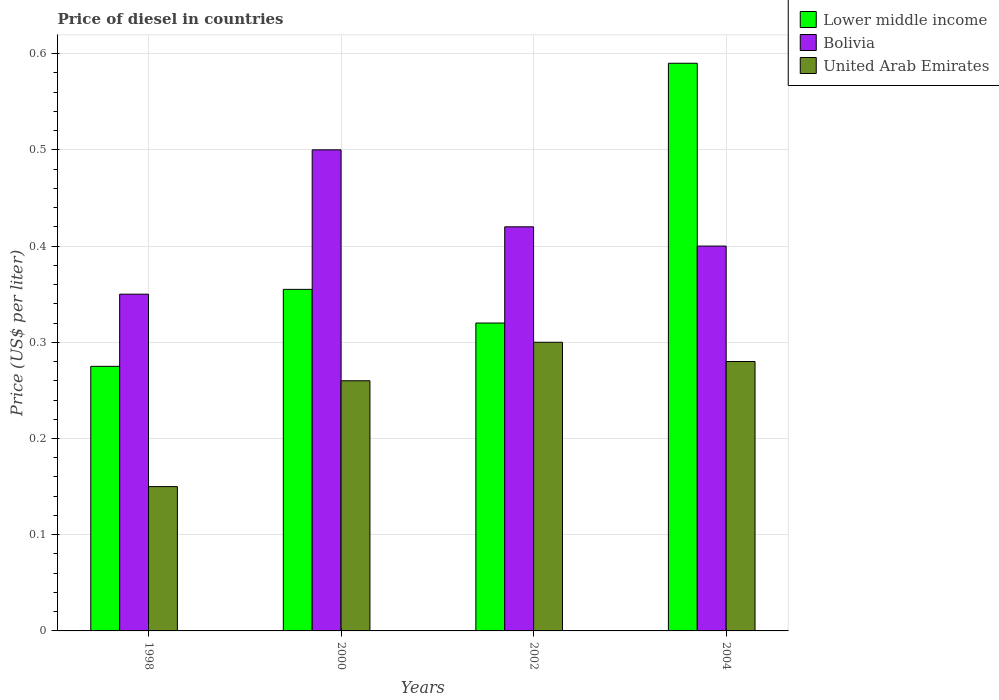Are the number of bars per tick equal to the number of legend labels?
Keep it short and to the point. Yes. What is the label of the 3rd group of bars from the left?
Offer a very short reply. 2002. In how many cases, is the number of bars for a given year not equal to the number of legend labels?
Your answer should be very brief. 0. What is the price of diesel in Lower middle income in 2002?
Provide a succinct answer. 0.32. Across all years, what is the maximum price of diesel in Bolivia?
Your answer should be compact. 0.5. Across all years, what is the minimum price of diesel in Lower middle income?
Your response must be concise. 0.28. In which year was the price of diesel in Bolivia maximum?
Offer a terse response. 2000. In which year was the price of diesel in Lower middle income minimum?
Offer a terse response. 1998. What is the difference between the price of diesel in United Arab Emirates in 2000 and that in 2004?
Offer a very short reply. -0.02. What is the difference between the price of diesel in Bolivia in 2002 and the price of diesel in United Arab Emirates in 2004?
Your answer should be very brief. 0.14. What is the average price of diesel in United Arab Emirates per year?
Keep it short and to the point. 0.25. In the year 2002, what is the difference between the price of diesel in United Arab Emirates and price of diesel in Bolivia?
Offer a very short reply. -0.12. What is the ratio of the price of diesel in United Arab Emirates in 1998 to that in 2000?
Provide a short and direct response. 0.58. What is the difference between the highest and the second highest price of diesel in Bolivia?
Provide a succinct answer. 0.08. What is the difference between the highest and the lowest price of diesel in Bolivia?
Offer a terse response. 0.15. In how many years, is the price of diesel in Bolivia greater than the average price of diesel in Bolivia taken over all years?
Ensure brevity in your answer.  2. Is the sum of the price of diesel in Bolivia in 2002 and 2004 greater than the maximum price of diesel in United Arab Emirates across all years?
Your answer should be very brief. Yes. What does the 3rd bar from the left in 2000 represents?
Ensure brevity in your answer.  United Arab Emirates. What does the 1st bar from the right in 2004 represents?
Give a very brief answer. United Arab Emirates. How many years are there in the graph?
Provide a short and direct response. 4. What is the difference between two consecutive major ticks on the Y-axis?
Keep it short and to the point. 0.1. Are the values on the major ticks of Y-axis written in scientific E-notation?
Keep it short and to the point. No. How many legend labels are there?
Give a very brief answer. 3. How are the legend labels stacked?
Offer a very short reply. Vertical. What is the title of the graph?
Offer a very short reply. Price of diesel in countries. What is the label or title of the Y-axis?
Your response must be concise. Price (US$ per liter). What is the Price (US$ per liter) of Lower middle income in 1998?
Ensure brevity in your answer.  0.28. What is the Price (US$ per liter) of Bolivia in 1998?
Provide a short and direct response. 0.35. What is the Price (US$ per liter) of Lower middle income in 2000?
Offer a very short reply. 0.35. What is the Price (US$ per liter) of Bolivia in 2000?
Offer a very short reply. 0.5. What is the Price (US$ per liter) of United Arab Emirates in 2000?
Your response must be concise. 0.26. What is the Price (US$ per liter) in Lower middle income in 2002?
Provide a short and direct response. 0.32. What is the Price (US$ per liter) in Bolivia in 2002?
Your answer should be compact. 0.42. What is the Price (US$ per liter) in Lower middle income in 2004?
Your answer should be very brief. 0.59. What is the Price (US$ per liter) of United Arab Emirates in 2004?
Make the answer very short. 0.28. Across all years, what is the maximum Price (US$ per liter) in Lower middle income?
Offer a terse response. 0.59. Across all years, what is the minimum Price (US$ per liter) of Lower middle income?
Ensure brevity in your answer.  0.28. Across all years, what is the minimum Price (US$ per liter) of Bolivia?
Provide a succinct answer. 0.35. What is the total Price (US$ per liter) in Lower middle income in the graph?
Keep it short and to the point. 1.54. What is the total Price (US$ per liter) of Bolivia in the graph?
Offer a very short reply. 1.67. What is the difference between the Price (US$ per liter) in Lower middle income in 1998 and that in 2000?
Provide a short and direct response. -0.08. What is the difference between the Price (US$ per liter) of Bolivia in 1998 and that in 2000?
Provide a short and direct response. -0.15. What is the difference between the Price (US$ per liter) in United Arab Emirates in 1998 and that in 2000?
Ensure brevity in your answer.  -0.11. What is the difference between the Price (US$ per liter) of Lower middle income in 1998 and that in 2002?
Provide a short and direct response. -0.04. What is the difference between the Price (US$ per liter) of Bolivia in 1998 and that in 2002?
Ensure brevity in your answer.  -0.07. What is the difference between the Price (US$ per liter) in United Arab Emirates in 1998 and that in 2002?
Make the answer very short. -0.15. What is the difference between the Price (US$ per liter) in Lower middle income in 1998 and that in 2004?
Your response must be concise. -0.32. What is the difference between the Price (US$ per liter) of United Arab Emirates in 1998 and that in 2004?
Provide a short and direct response. -0.13. What is the difference between the Price (US$ per liter) of Lower middle income in 2000 and that in 2002?
Your response must be concise. 0.04. What is the difference between the Price (US$ per liter) of United Arab Emirates in 2000 and that in 2002?
Offer a terse response. -0.04. What is the difference between the Price (US$ per liter) in Lower middle income in 2000 and that in 2004?
Your answer should be compact. -0.23. What is the difference between the Price (US$ per liter) in Bolivia in 2000 and that in 2004?
Give a very brief answer. 0.1. What is the difference between the Price (US$ per liter) of United Arab Emirates in 2000 and that in 2004?
Your response must be concise. -0.02. What is the difference between the Price (US$ per liter) in Lower middle income in 2002 and that in 2004?
Provide a succinct answer. -0.27. What is the difference between the Price (US$ per liter) of Bolivia in 2002 and that in 2004?
Offer a very short reply. 0.02. What is the difference between the Price (US$ per liter) of Lower middle income in 1998 and the Price (US$ per liter) of Bolivia in 2000?
Ensure brevity in your answer.  -0.23. What is the difference between the Price (US$ per liter) in Lower middle income in 1998 and the Price (US$ per liter) in United Arab Emirates in 2000?
Your response must be concise. 0.01. What is the difference between the Price (US$ per liter) in Bolivia in 1998 and the Price (US$ per liter) in United Arab Emirates in 2000?
Your answer should be compact. 0.09. What is the difference between the Price (US$ per liter) of Lower middle income in 1998 and the Price (US$ per liter) of Bolivia in 2002?
Keep it short and to the point. -0.14. What is the difference between the Price (US$ per liter) of Lower middle income in 1998 and the Price (US$ per liter) of United Arab Emirates in 2002?
Provide a succinct answer. -0.03. What is the difference between the Price (US$ per liter) in Lower middle income in 1998 and the Price (US$ per liter) in Bolivia in 2004?
Your answer should be compact. -0.12. What is the difference between the Price (US$ per liter) in Lower middle income in 1998 and the Price (US$ per liter) in United Arab Emirates in 2004?
Ensure brevity in your answer.  -0.01. What is the difference between the Price (US$ per liter) of Bolivia in 1998 and the Price (US$ per liter) of United Arab Emirates in 2004?
Provide a succinct answer. 0.07. What is the difference between the Price (US$ per liter) of Lower middle income in 2000 and the Price (US$ per liter) of Bolivia in 2002?
Provide a short and direct response. -0.07. What is the difference between the Price (US$ per liter) of Lower middle income in 2000 and the Price (US$ per liter) of United Arab Emirates in 2002?
Your answer should be very brief. 0.06. What is the difference between the Price (US$ per liter) in Bolivia in 2000 and the Price (US$ per liter) in United Arab Emirates in 2002?
Offer a terse response. 0.2. What is the difference between the Price (US$ per liter) in Lower middle income in 2000 and the Price (US$ per liter) in Bolivia in 2004?
Make the answer very short. -0.04. What is the difference between the Price (US$ per liter) of Lower middle income in 2000 and the Price (US$ per liter) of United Arab Emirates in 2004?
Keep it short and to the point. 0.07. What is the difference between the Price (US$ per liter) of Bolivia in 2000 and the Price (US$ per liter) of United Arab Emirates in 2004?
Make the answer very short. 0.22. What is the difference between the Price (US$ per liter) in Lower middle income in 2002 and the Price (US$ per liter) in Bolivia in 2004?
Offer a terse response. -0.08. What is the difference between the Price (US$ per liter) of Bolivia in 2002 and the Price (US$ per liter) of United Arab Emirates in 2004?
Provide a short and direct response. 0.14. What is the average Price (US$ per liter) in Lower middle income per year?
Your answer should be compact. 0.39. What is the average Price (US$ per liter) of Bolivia per year?
Your response must be concise. 0.42. What is the average Price (US$ per liter) in United Arab Emirates per year?
Offer a terse response. 0.25. In the year 1998, what is the difference between the Price (US$ per liter) of Lower middle income and Price (US$ per liter) of Bolivia?
Your answer should be very brief. -0.07. In the year 1998, what is the difference between the Price (US$ per liter) of Lower middle income and Price (US$ per liter) of United Arab Emirates?
Your response must be concise. 0.12. In the year 2000, what is the difference between the Price (US$ per liter) in Lower middle income and Price (US$ per liter) in Bolivia?
Ensure brevity in your answer.  -0.14. In the year 2000, what is the difference between the Price (US$ per liter) of Lower middle income and Price (US$ per liter) of United Arab Emirates?
Offer a very short reply. 0.1. In the year 2000, what is the difference between the Price (US$ per liter) in Bolivia and Price (US$ per liter) in United Arab Emirates?
Offer a terse response. 0.24. In the year 2002, what is the difference between the Price (US$ per liter) of Lower middle income and Price (US$ per liter) of United Arab Emirates?
Provide a short and direct response. 0.02. In the year 2002, what is the difference between the Price (US$ per liter) of Bolivia and Price (US$ per liter) of United Arab Emirates?
Offer a very short reply. 0.12. In the year 2004, what is the difference between the Price (US$ per liter) of Lower middle income and Price (US$ per liter) of Bolivia?
Your answer should be very brief. 0.19. In the year 2004, what is the difference between the Price (US$ per liter) of Lower middle income and Price (US$ per liter) of United Arab Emirates?
Ensure brevity in your answer.  0.31. In the year 2004, what is the difference between the Price (US$ per liter) in Bolivia and Price (US$ per liter) in United Arab Emirates?
Your answer should be very brief. 0.12. What is the ratio of the Price (US$ per liter) in Lower middle income in 1998 to that in 2000?
Provide a succinct answer. 0.77. What is the ratio of the Price (US$ per liter) of United Arab Emirates in 1998 to that in 2000?
Your response must be concise. 0.58. What is the ratio of the Price (US$ per liter) of Lower middle income in 1998 to that in 2002?
Your answer should be compact. 0.86. What is the ratio of the Price (US$ per liter) of United Arab Emirates in 1998 to that in 2002?
Offer a terse response. 0.5. What is the ratio of the Price (US$ per liter) in Lower middle income in 1998 to that in 2004?
Make the answer very short. 0.47. What is the ratio of the Price (US$ per liter) in United Arab Emirates in 1998 to that in 2004?
Ensure brevity in your answer.  0.54. What is the ratio of the Price (US$ per liter) of Lower middle income in 2000 to that in 2002?
Make the answer very short. 1.11. What is the ratio of the Price (US$ per liter) in Bolivia in 2000 to that in 2002?
Your response must be concise. 1.19. What is the ratio of the Price (US$ per liter) in United Arab Emirates in 2000 to that in 2002?
Provide a succinct answer. 0.87. What is the ratio of the Price (US$ per liter) in Lower middle income in 2000 to that in 2004?
Keep it short and to the point. 0.6. What is the ratio of the Price (US$ per liter) of United Arab Emirates in 2000 to that in 2004?
Provide a succinct answer. 0.93. What is the ratio of the Price (US$ per liter) in Lower middle income in 2002 to that in 2004?
Ensure brevity in your answer.  0.54. What is the ratio of the Price (US$ per liter) in Bolivia in 2002 to that in 2004?
Ensure brevity in your answer.  1.05. What is the ratio of the Price (US$ per liter) of United Arab Emirates in 2002 to that in 2004?
Give a very brief answer. 1.07. What is the difference between the highest and the second highest Price (US$ per liter) of Lower middle income?
Keep it short and to the point. 0.23. What is the difference between the highest and the second highest Price (US$ per liter) in Bolivia?
Ensure brevity in your answer.  0.08. What is the difference between the highest and the second highest Price (US$ per liter) of United Arab Emirates?
Provide a succinct answer. 0.02. What is the difference between the highest and the lowest Price (US$ per liter) of Lower middle income?
Offer a very short reply. 0.32. What is the difference between the highest and the lowest Price (US$ per liter) in Bolivia?
Your answer should be very brief. 0.15. 